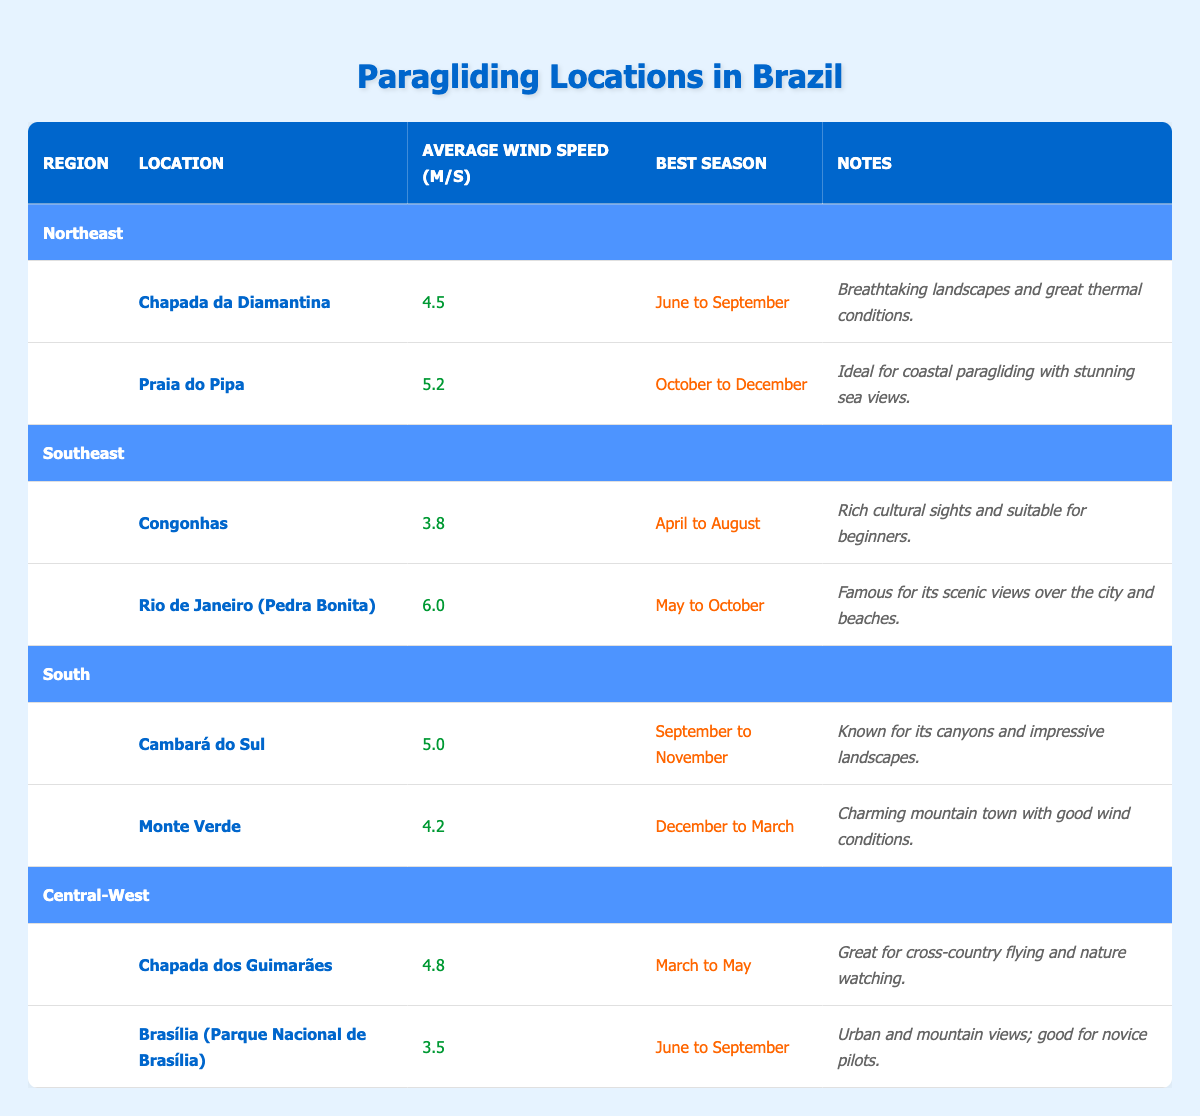What is the average wind speed at Praia do Pipa? According to the table, Praia do Pipa has an average wind speed of 5.2 m/s.
Answer: 5.2 m/s Which paragliding location in the Southeast has the highest average wind speed? In the Southeast, the location with the highest average wind speed is Rio de Janeiro (Pedra Bonita) at 6.0 m/s.
Answer: Rio de Janeiro (Pedra Bonita) Does Chapada dos Guimarães have a better average wind speed than Brasília? Chapada dos Guimarães has an average wind speed of 4.8 m/s, while Brasília has 3.5 m/s. Therefore, the statement is true.
Answer: Yes What is the best season for paragliding at Cambará do Sul? The best season for paragliding at Cambará do Sul is from September to November according to the table.
Answer: September to November Calculate the total average wind speed for all locations in the Central-West region. The wind speeds in the Central-West region are 4.8 m/s (Chapada dos Guimarães) and 3.5 m/s (Brasília), making the total 4.8 + 3.5 = 8.3 m/s. Since there are 2 locations, the average is 8.3 / 2 = 4.15 m/s.
Answer: 4.15 m/s Which region has the lowest average wind speed across all its locations? We need to compute the average wind speeds for each region. For Northeast: (4.5 + 5.2) / 2 = 4.85 m/s, Southeast: (3.8 + 6.0) / 2 = 4.9 m/s, South: (5.0 + 4.2) / 2 = 4.6 m/s, Central-West: (4.8 + 3.5) / 2 = 4.15 m/s. The Central-West has the lowest average wind speed of 4.15 m/s.
Answer: Central-West Is Congonhas suitable for novice pilots according to the table? The table notes that Congonhas is suitable for beginners, confirming that it is suitable for novice pilots.
Answer: Yes What are the average wind speeds for locations in the Northeast region? The average wind speeds for the Northeast locations are 4.5 m/s for Chapada da Diamantina and 5.2 m/s for Praia do Pipa.
Answer: 4.5 m/s and 5.2 m/s What is the common characteristic of the best season for paragliding at locations in the Southeast? The best seasons for both locations in the Southeast (Congonhas and Rio de Janeiro) either fall in the middle of the year (April to October), suggesting a preference for warmer months.
Answer: Warmer months 